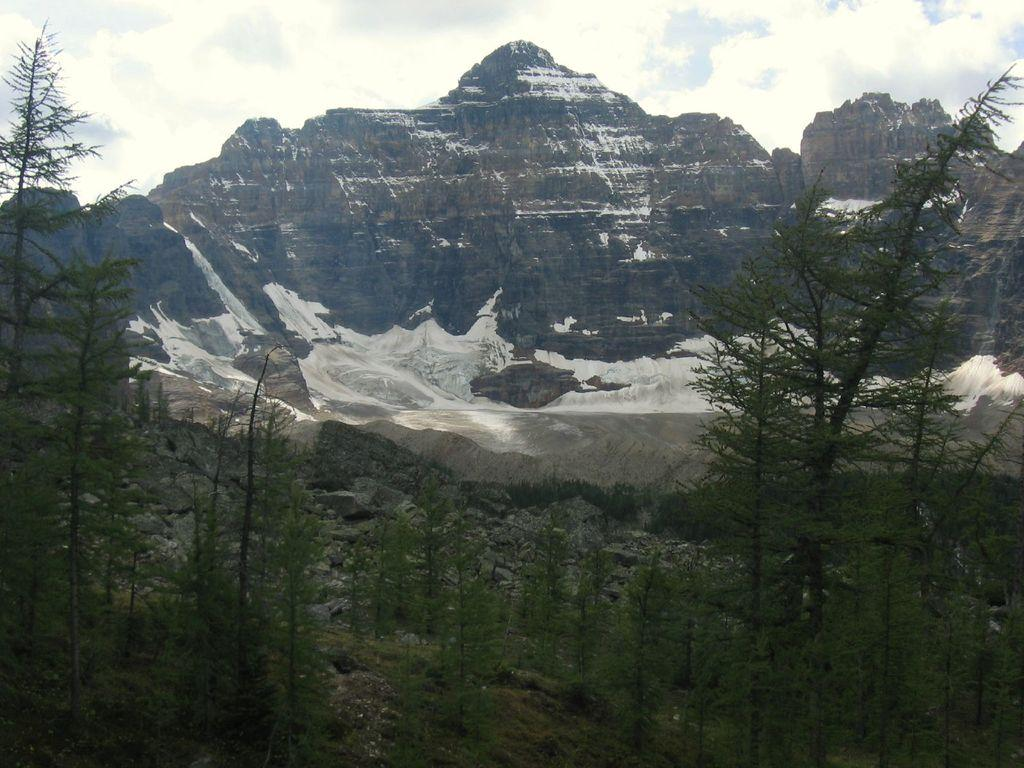What type of vegetation can be seen in the image? There are trees in the image. What is visible behind the trees? There are hills visible behind the trees. Can you describe the landscape feature between the hills? There is a pond between the hills. What type of wool is being produced by the machine in the image? There is no machine or wool present in the image; it features trees, hills, and a pond. 